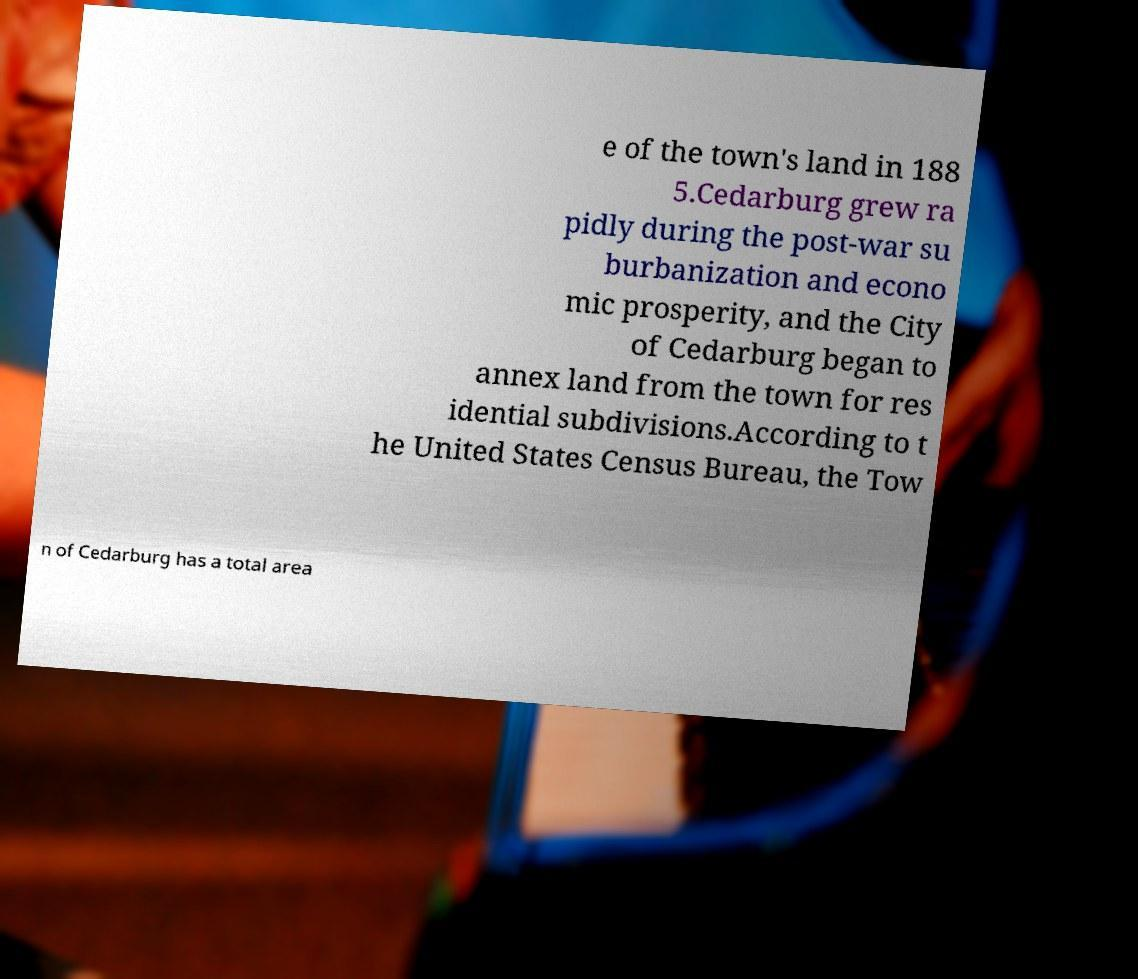Could you assist in decoding the text presented in this image and type it out clearly? e of the town's land in 188 5.Cedarburg grew ra pidly during the post-war su burbanization and econo mic prosperity, and the City of Cedarburg began to annex land from the town for res idential subdivisions.According to t he United States Census Bureau, the Tow n of Cedarburg has a total area 